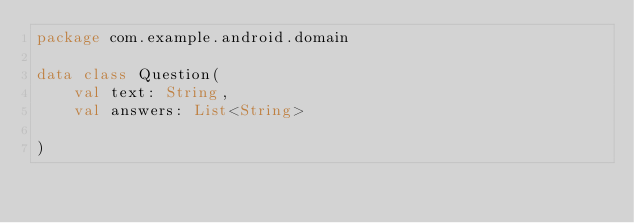<code> <loc_0><loc_0><loc_500><loc_500><_Kotlin_>package com.example.android.domain

data class Question(
    val text: String,
    val answers: List<String>

)</code> 